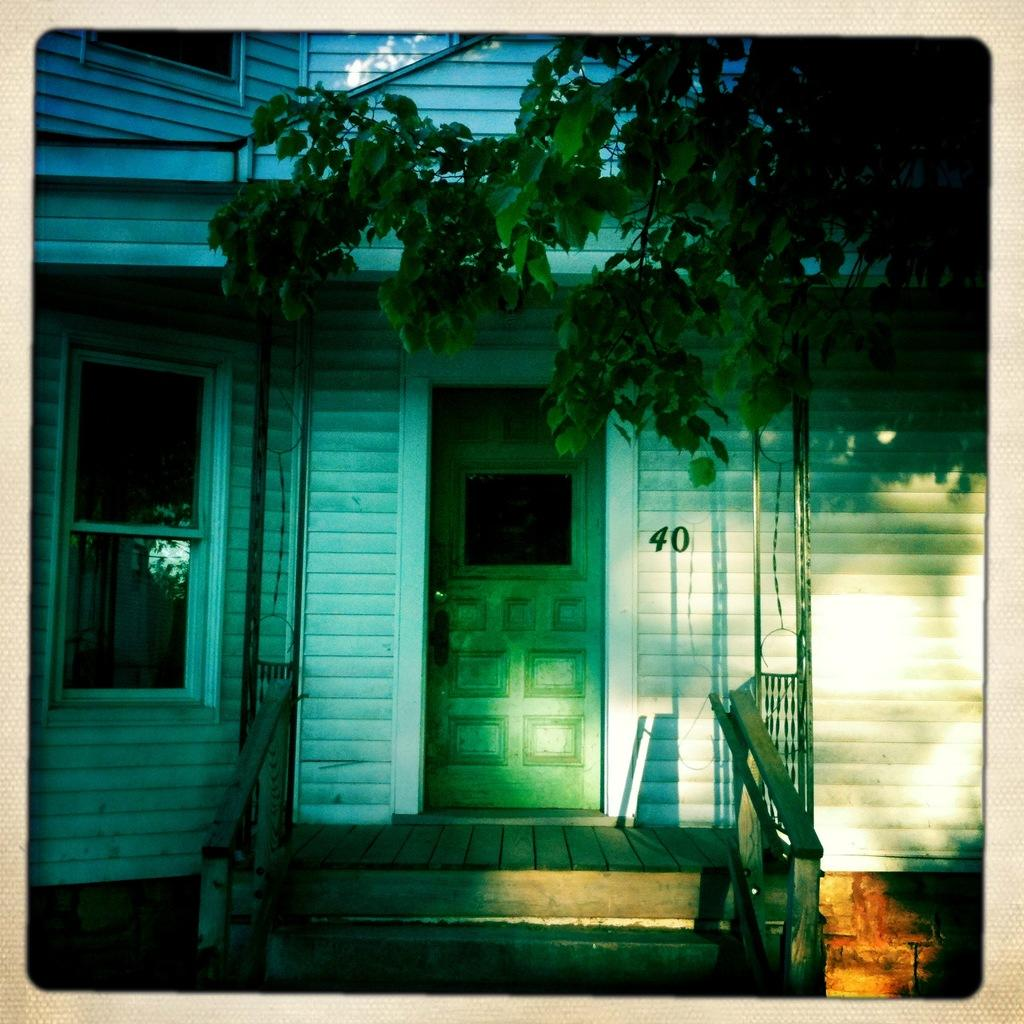What type of structure is visible in the image? There is a house in the image. What features can be seen on the house? The house has a window and a door. Where is the tree located in the image? The tree is in the top right corner of the image. How many grapes are hanging from the tree in the image? There are no grapes visible in the image, as the tree is not a grapevine. 